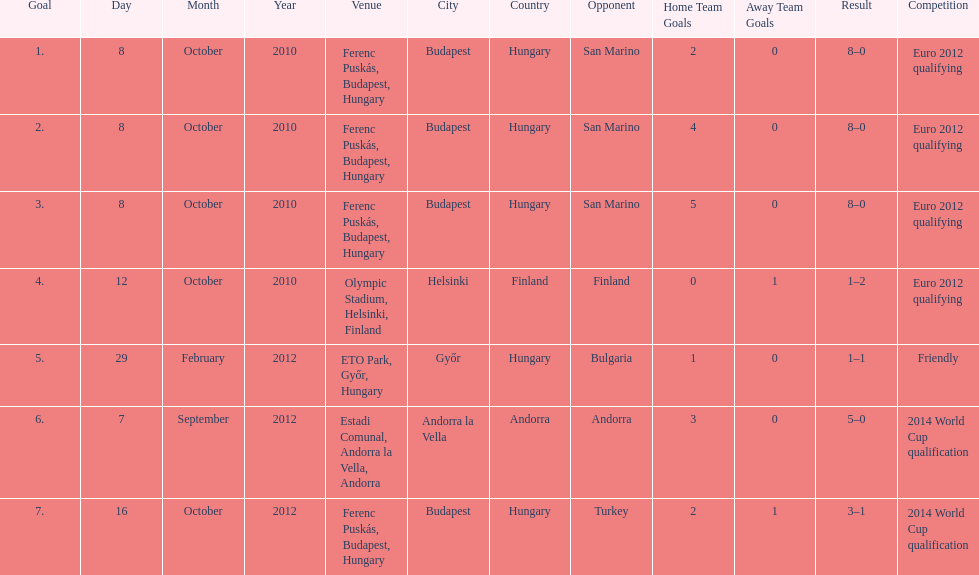When did ádám szalai make his first international goal? 8 October 2010. 